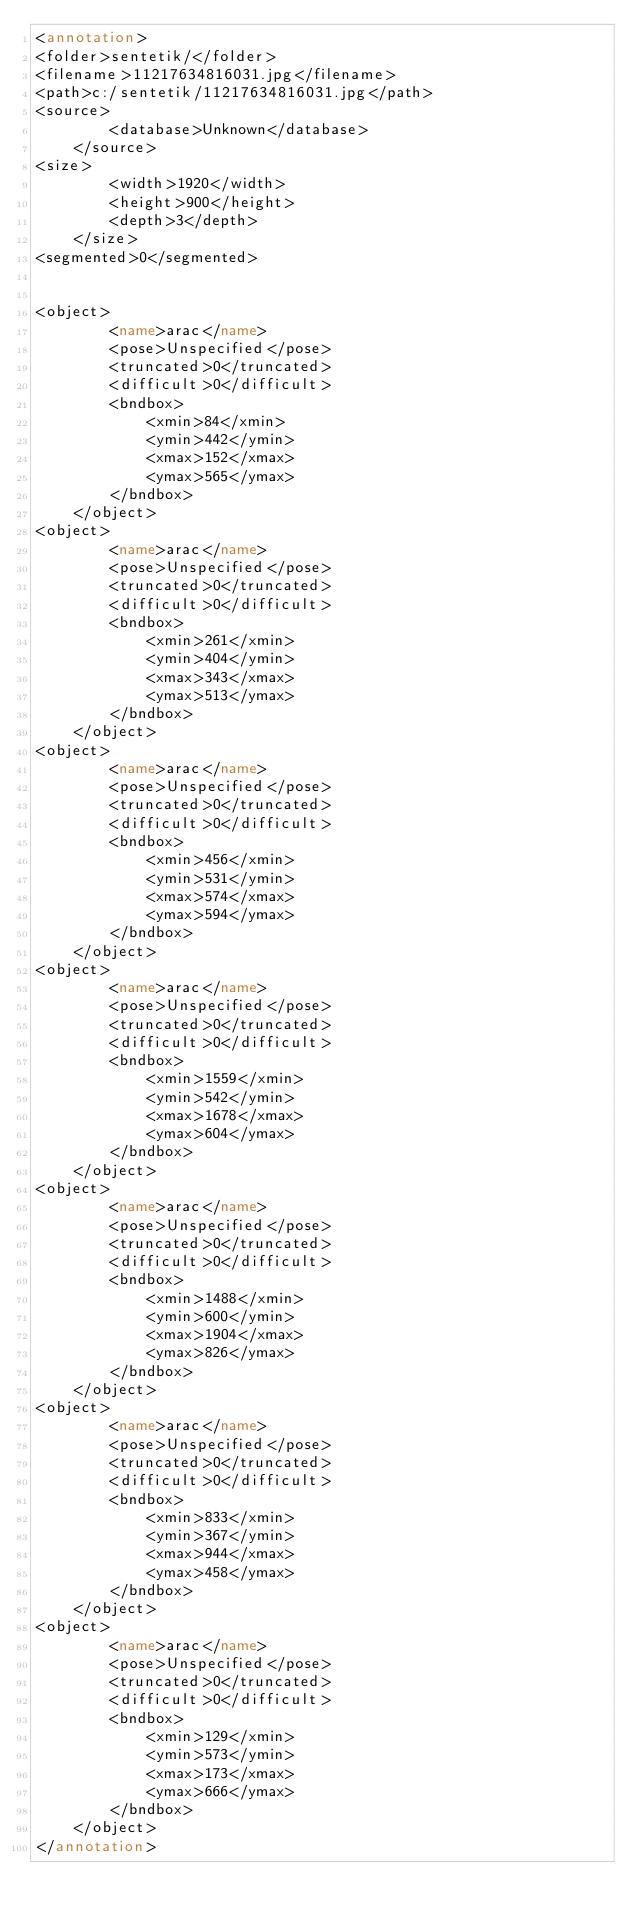Convert code to text. <code><loc_0><loc_0><loc_500><loc_500><_XML_><annotation>
<folder>sentetik/</folder>
<filename>11217634816031.jpg</filename>
<path>c:/sentetik/11217634816031.jpg</path>
<source>
		<database>Unknown</database>
	</source>
<size>
		<width>1920</width>
		<height>900</height>
		<depth>3</depth>
	</size>
<segmented>0</segmented>


<object>
		<name>arac</name>
		<pose>Unspecified</pose>
		<truncated>0</truncated>
		<difficult>0</difficult>
		<bndbox>
			<xmin>84</xmin>
			<ymin>442</ymin>
			<xmax>152</xmax>
			<ymax>565</ymax>
		</bndbox>
	</object>
<object>
		<name>arac</name>
		<pose>Unspecified</pose>
		<truncated>0</truncated>
		<difficult>0</difficult>
		<bndbox>
			<xmin>261</xmin>
			<ymin>404</ymin>
			<xmax>343</xmax>
			<ymax>513</ymax>
		</bndbox>
	</object>
<object>
		<name>arac</name>
		<pose>Unspecified</pose>
		<truncated>0</truncated>
		<difficult>0</difficult>
		<bndbox>
			<xmin>456</xmin>
			<ymin>531</ymin>
			<xmax>574</xmax>
			<ymax>594</ymax>
		</bndbox>
	</object>
<object>
		<name>arac</name>
		<pose>Unspecified</pose>
		<truncated>0</truncated>
		<difficult>0</difficult>
		<bndbox>
			<xmin>1559</xmin>
			<ymin>542</ymin>
			<xmax>1678</xmax>
			<ymax>604</ymax>
		</bndbox>
	</object>
<object>
		<name>arac</name>
		<pose>Unspecified</pose>
		<truncated>0</truncated>
		<difficult>0</difficult>
		<bndbox>
			<xmin>1488</xmin>
			<ymin>600</ymin>
			<xmax>1904</xmax>
			<ymax>826</ymax>
		</bndbox>
	</object>
<object>
		<name>arac</name>
		<pose>Unspecified</pose>
		<truncated>0</truncated>
		<difficult>0</difficult>
		<bndbox>
			<xmin>833</xmin>
			<ymin>367</ymin>
			<xmax>944</xmax>
			<ymax>458</ymax>
		</bndbox>
	</object>
<object>
		<name>arac</name>
		<pose>Unspecified</pose>
		<truncated>0</truncated>
		<difficult>0</difficult>
		<bndbox>
			<xmin>129</xmin>
			<ymin>573</ymin>
			<xmax>173</xmax>
			<ymax>666</ymax>
		</bndbox>
	</object>
</annotation></code> 